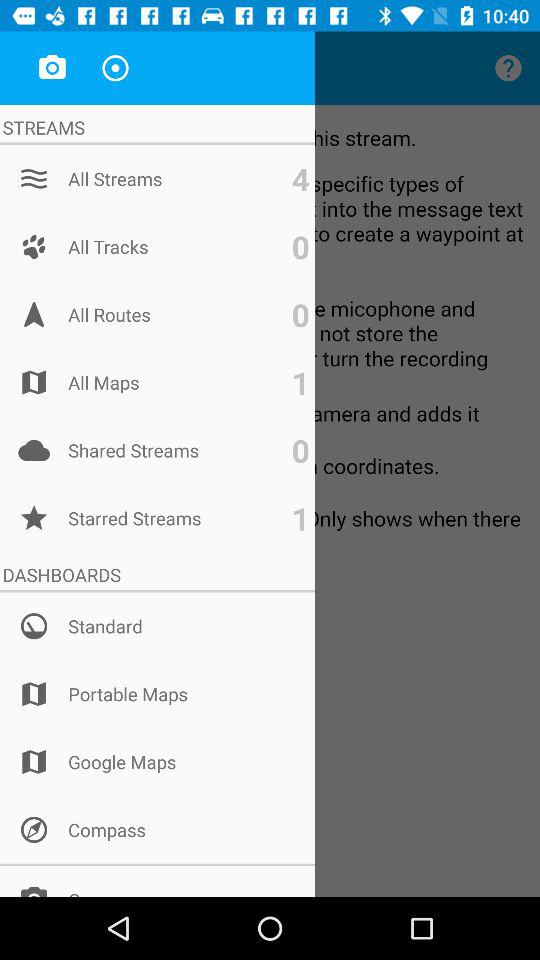What are the available options in the "DASHBOARDS"? The available items in the "DASHBOARDS" are "Standard", "Portable Maps", "Google Maps" and "Compass". 